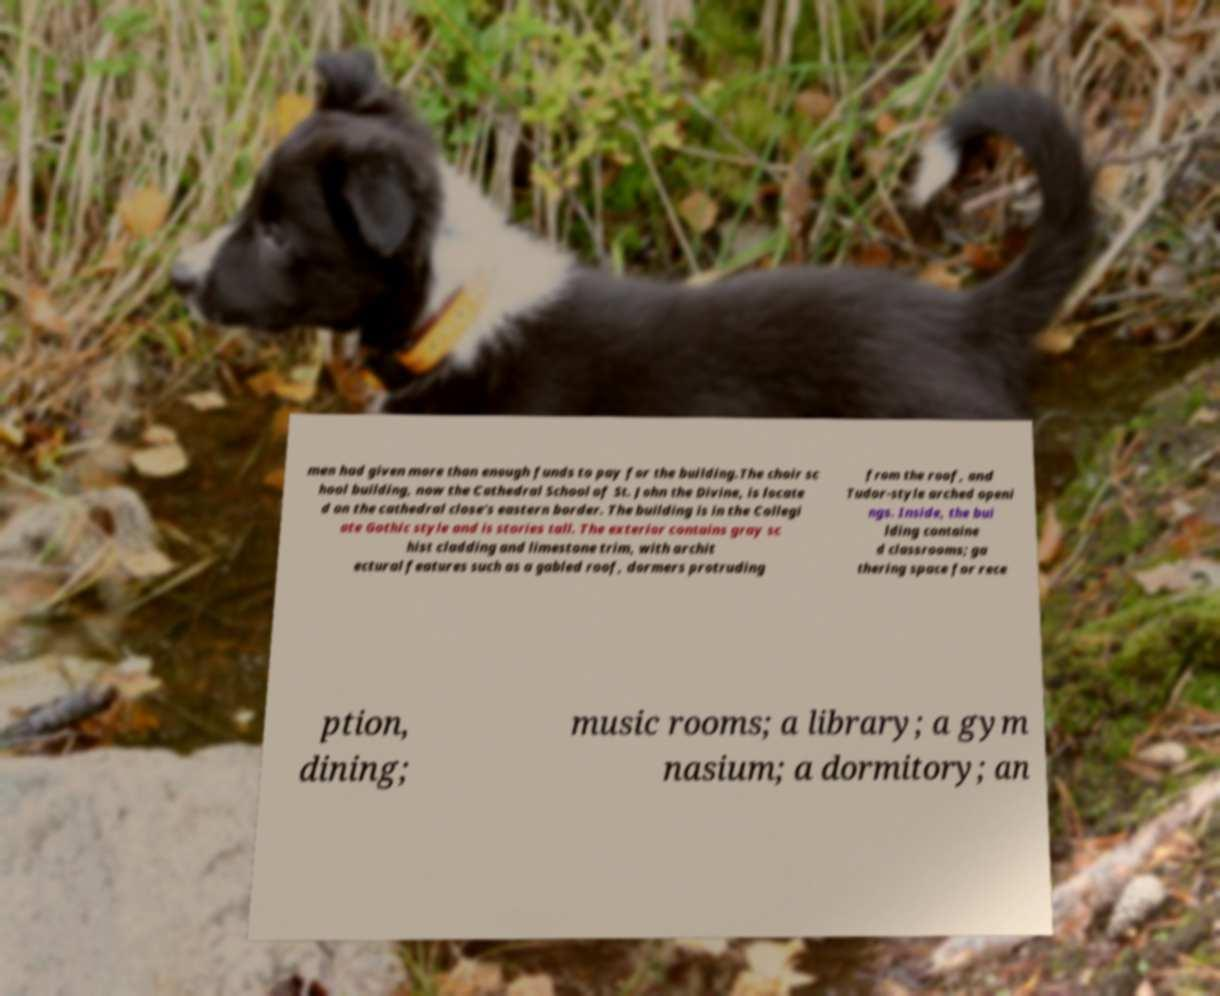I need the written content from this picture converted into text. Can you do that? men had given more than enough funds to pay for the building.The choir sc hool building, now the Cathedral School of St. John the Divine, is locate d on the cathedral close's eastern border. The building is in the Collegi ate Gothic style and is stories tall. The exterior contains gray sc hist cladding and limestone trim, with archit ectural features such as a gabled roof, dormers protruding from the roof, and Tudor-style arched openi ngs. Inside, the bui lding containe d classrooms; ga thering space for rece ption, dining; music rooms; a library; a gym nasium; a dormitory; an 